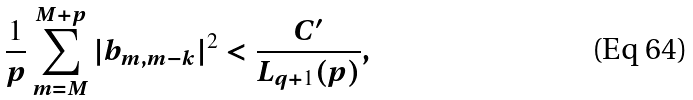<formula> <loc_0><loc_0><loc_500><loc_500>\frac { 1 } { p } \sum _ { m = M } ^ { M + p } | b _ { m , m - k } | ^ { 2 } < \frac { C ^ { \prime } } { L _ { q + 1 } ( p ) } ,</formula> 